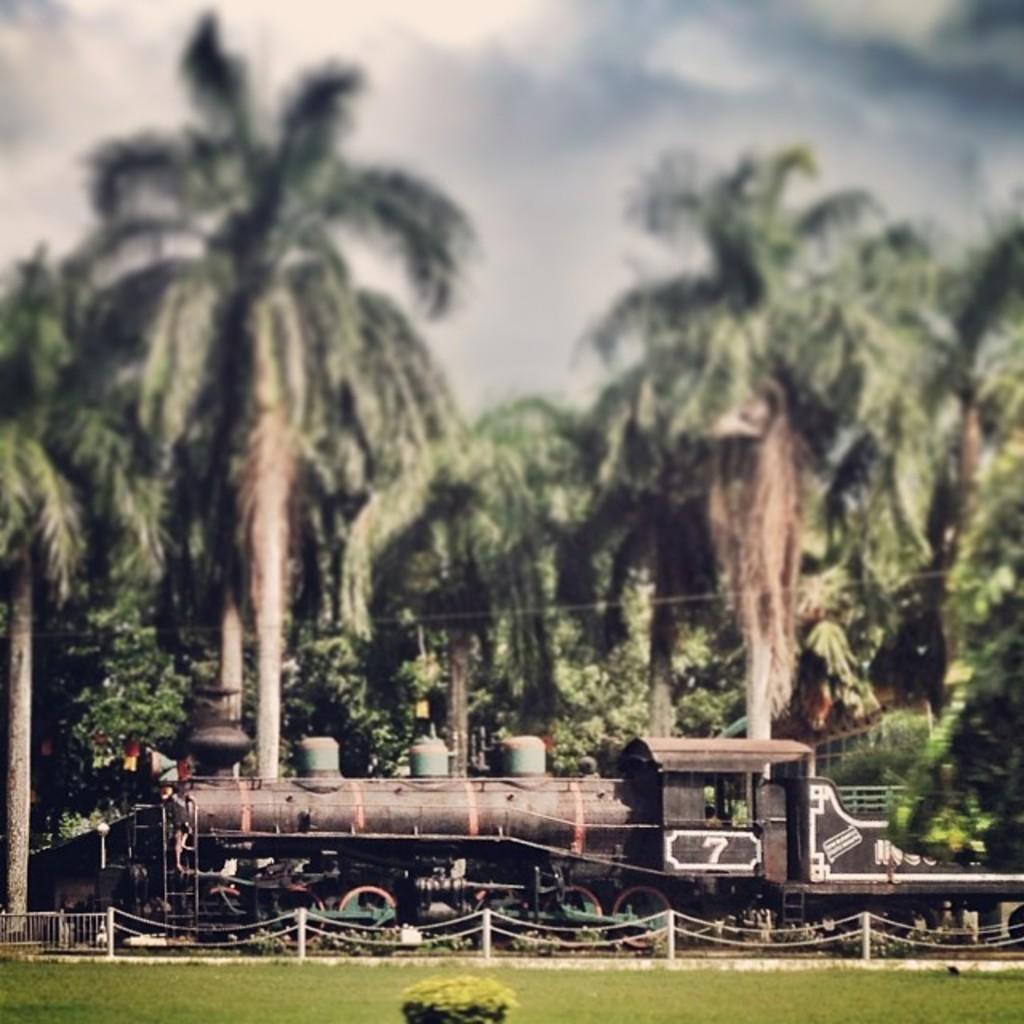Can you describe this image briefly? In this image I can see the railing, poles and the metal chains. I can see the train. In the background I can see the shed, many trees, clouds and the sky. 